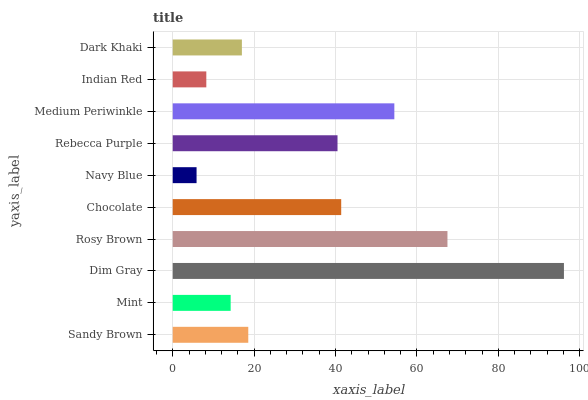Is Navy Blue the minimum?
Answer yes or no. Yes. Is Dim Gray the maximum?
Answer yes or no. Yes. Is Mint the minimum?
Answer yes or no. No. Is Mint the maximum?
Answer yes or no. No. Is Sandy Brown greater than Mint?
Answer yes or no. Yes. Is Mint less than Sandy Brown?
Answer yes or no. Yes. Is Mint greater than Sandy Brown?
Answer yes or no. No. Is Sandy Brown less than Mint?
Answer yes or no. No. Is Rebecca Purple the high median?
Answer yes or no. Yes. Is Sandy Brown the low median?
Answer yes or no. Yes. Is Indian Red the high median?
Answer yes or no. No. Is Medium Periwinkle the low median?
Answer yes or no. No. 